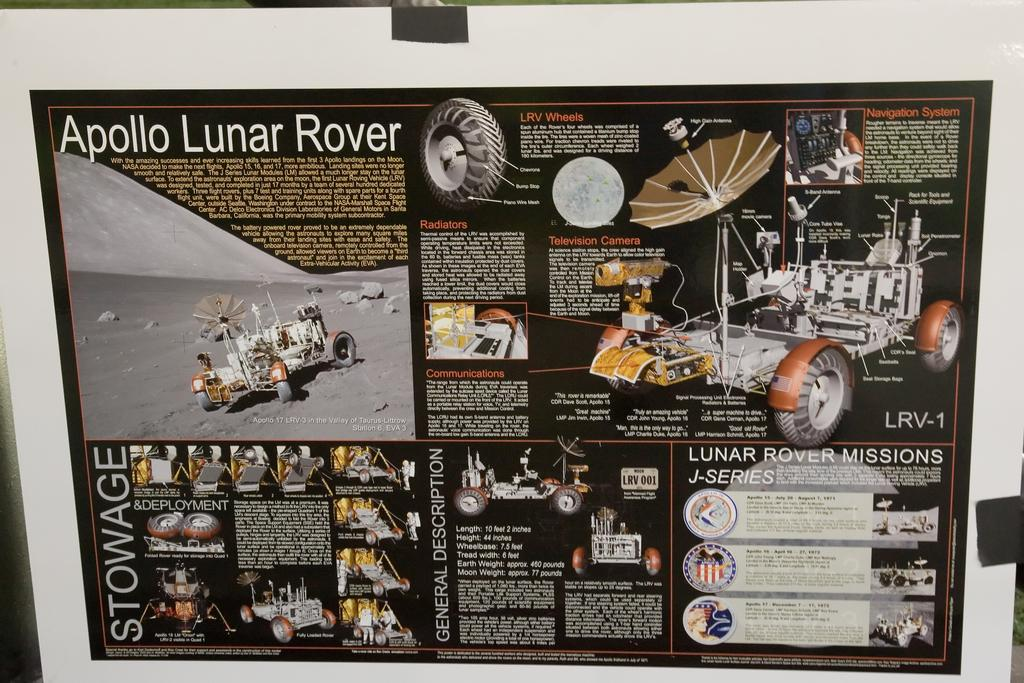<image>
Give a short and clear explanation of the subsequent image. A display showing information about the Apollo Lunar Rover. 